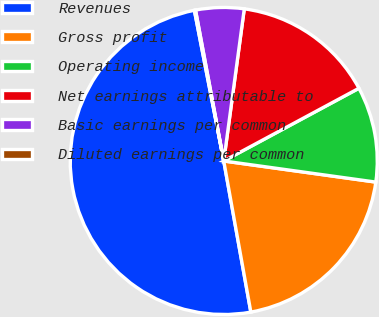Convert chart to OTSL. <chart><loc_0><loc_0><loc_500><loc_500><pie_chart><fcel>Revenues<fcel>Gross profit<fcel>Operating income<fcel>Net earnings attributable to<fcel>Basic earnings per common<fcel>Diluted earnings per common<nl><fcel>49.76%<fcel>19.98%<fcel>10.05%<fcel>15.01%<fcel>5.08%<fcel>0.12%<nl></chart> 